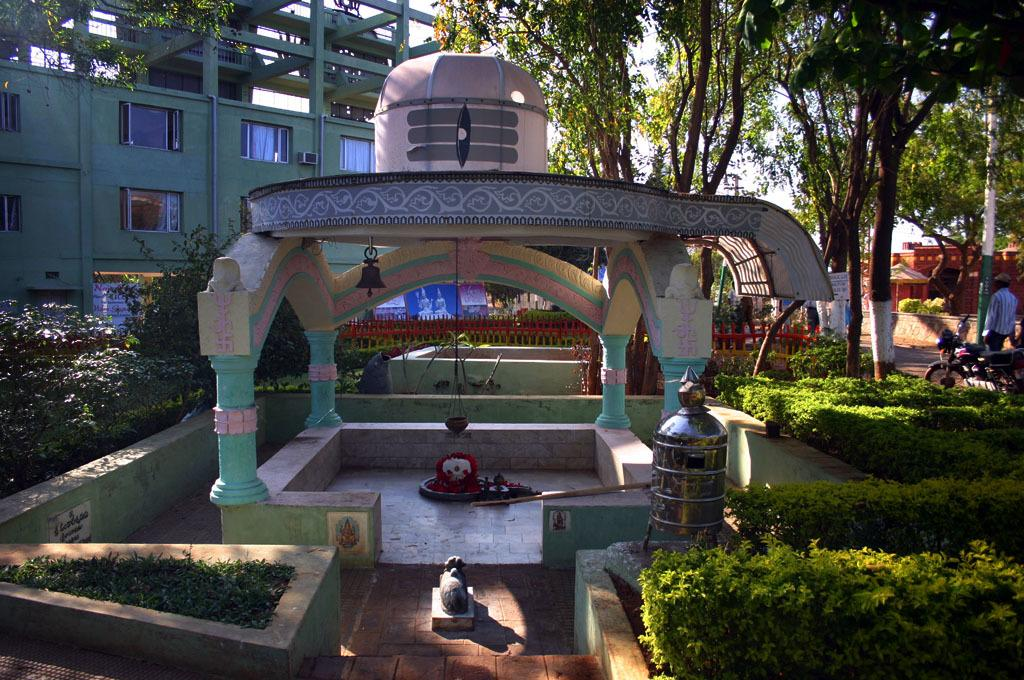What type of vegetation can be seen in the image? There are plants and grass in the image. What object made of metal can be seen in the image? There is a metal box in the image. What mode of transportation is present in the image? There is a motorbike in the image. Who is present in the image? There is a person standing in the image. What type of natural structures are visible in the image? There are trees in the image. What type of man-made structures are visible in the image? There are buildings in the image. What can be seen in the background of the image? The sky is visible in the background of the image. What type of map is the person holding in the image? There is no map present in the image; the person is simply standing. What type of meal is the person cooking in the image? There is no cooking or food preparation visible in the image. Who is the person standing next to in the image? The provided facts do not mention anyone else standing next to the person, so we cannot answer this question. 